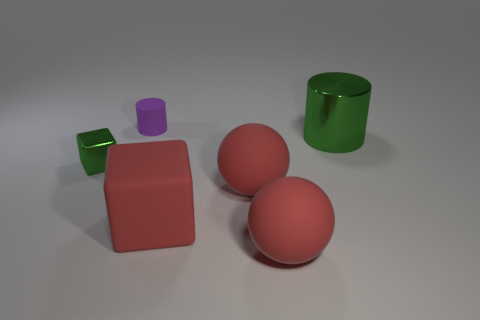There is a sphere behind the big thing that is in front of the red rubber cube that is right of the small matte cylinder; what is its material?
Your answer should be compact. Rubber. There is a green object that is to the left of the small object that is behind the large green metallic thing; what size is it?
Keep it short and to the point. Small. There is another thing that is the same shape as the tiny purple object; what color is it?
Offer a very short reply. Green. How many large metallic things are the same color as the metal cylinder?
Offer a terse response. 0. Is the size of the purple rubber object the same as the green shiny block?
Provide a short and direct response. Yes. What is the green cube made of?
Your answer should be compact. Metal. What color is the small thing that is the same material as the red block?
Your response must be concise. Purple. Is the material of the big green cylinder the same as the block that is left of the tiny rubber cylinder?
Make the answer very short. Yes. How many big objects have the same material as the green block?
Keep it short and to the point. 1. What shape is the green shiny object behind the tiny green metal thing?
Ensure brevity in your answer.  Cylinder. 